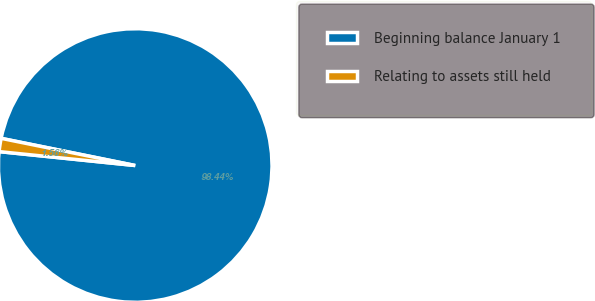Convert chart to OTSL. <chart><loc_0><loc_0><loc_500><loc_500><pie_chart><fcel>Beginning balance January 1<fcel>Relating to assets still held<nl><fcel>98.44%<fcel>1.56%<nl></chart> 